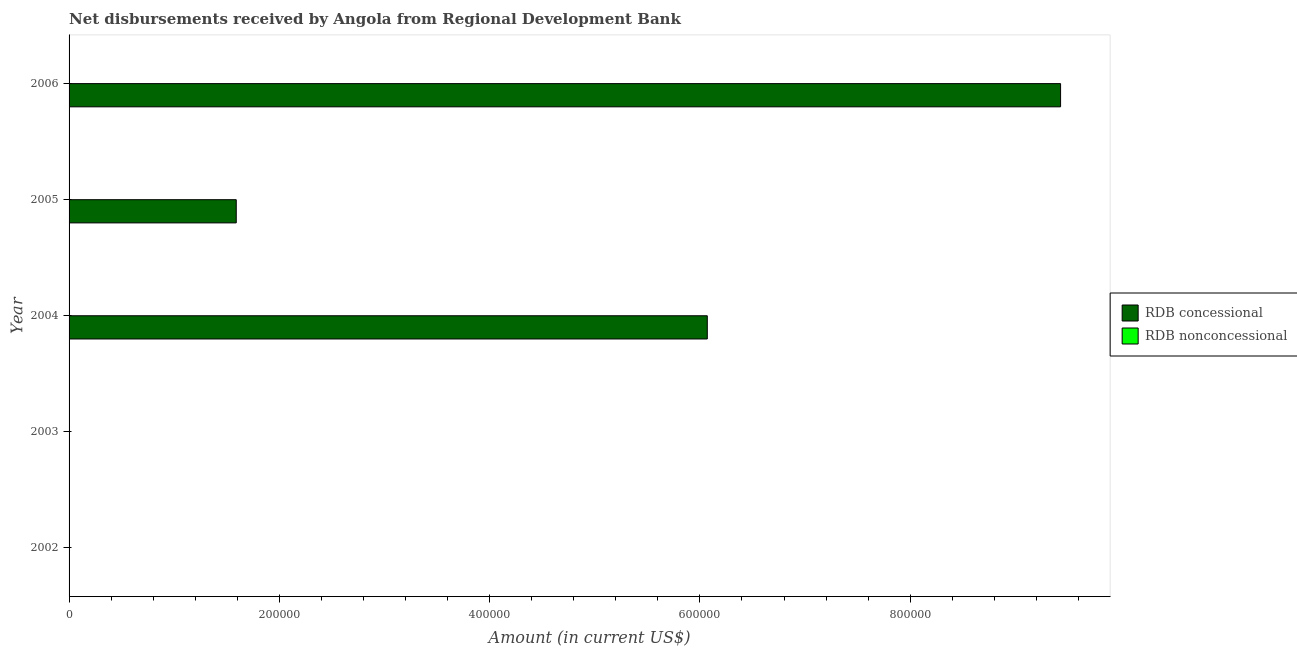How many different coloured bars are there?
Your answer should be compact. 1. How many bars are there on the 4th tick from the top?
Your answer should be compact. 0. Across all years, what is the maximum net concessional disbursements from rdb?
Provide a short and direct response. 9.43e+05. What is the difference between the net concessional disbursements from rdb in 2005 and that in 2006?
Offer a very short reply. -7.84e+05. What is the average net concessional disbursements from rdb per year?
Provide a short and direct response. 3.42e+05. In how many years, is the net non concessional disbursements from rdb greater than 600000 US$?
Provide a short and direct response. 0. What is the ratio of the net concessional disbursements from rdb in 2005 to that in 2006?
Give a very brief answer. 0.17. Is the net concessional disbursements from rdb in 2004 less than that in 2006?
Your answer should be compact. Yes. What is the difference between the highest and the second highest net concessional disbursements from rdb?
Provide a succinct answer. 3.36e+05. What is the difference between the highest and the lowest net concessional disbursements from rdb?
Make the answer very short. 9.43e+05. How many bars are there?
Ensure brevity in your answer.  3. How many years are there in the graph?
Your answer should be very brief. 5. What is the difference between two consecutive major ticks on the X-axis?
Your answer should be very brief. 2.00e+05. Are the values on the major ticks of X-axis written in scientific E-notation?
Your response must be concise. No. Does the graph contain any zero values?
Keep it short and to the point. Yes. Does the graph contain grids?
Provide a short and direct response. No. What is the title of the graph?
Your answer should be compact. Net disbursements received by Angola from Regional Development Bank. Does "Banks" appear as one of the legend labels in the graph?
Your response must be concise. No. What is the label or title of the X-axis?
Your answer should be compact. Amount (in current US$). What is the Amount (in current US$) in RDB nonconcessional in 2002?
Provide a succinct answer. 0. What is the Amount (in current US$) in RDB nonconcessional in 2003?
Your response must be concise. 0. What is the Amount (in current US$) of RDB concessional in 2004?
Ensure brevity in your answer.  6.07e+05. What is the Amount (in current US$) of RDB concessional in 2005?
Ensure brevity in your answer.  1.59e+05. What is the Amount (in current US$) of RDB nonconcessional in 2005?
Keep it short and to the point. 0. What is the Amount (in current US$) in RDB concessional in 2006?
Your answer should be very brief. 9.43e+05. What is the Amount (in current US$) of RDB nonconcessional in 2006?
Ensure brevity in your answer.  0. Across all years, what is the maximum Amount (in current US$) of RDB concessional?
Offer a terse response. 9.43e+05. Across all years, what is the minimum Amount (in current US$) of RDB concessional?
Offer a very short reply. 0. What is the total Amount (in current US$) in RDB concessional in the graph?
Make the answer very short. 1.71e+06. What is the difference between the Amount (in current US$) in RDB concessional in 2004 and that in 2005?
Your answer should be very brief. 4.48e+05. What is the difference between the Amount (in current US$) in RDB concessional in 2004 and that in 2006?
Your answer should be very brief. -3.36e+05. What is the difference between the Amount (in current US$) of RDB concessional in 2005 and that in 2006?
Keep it short and to the point. -7.84e+05. What is the average Amount (in current US$) in RDB concessional per year?
Your response must be concise. 3.42e+05. What is the average Amount (in current US$) in RDB nonconcessional per year?
Offer a very short reply. 0. What is the ratio of the Amount (in current US$) in RDB concessional in 2004 to that in 2005?
Your answer should be compact. 3.82. What is the ratio of the Amount (in current US$) of RDB concessional in 2004 to that in 2006?
Your answer should be very brief. 0.64. What is the ratio of the Amount (in current US$) of RDB concessional in 2005 to that in 2006?
Your answer should be very brief. 0.17. What is the difference between the highest and the second highest Amount (in current US$) of RDB concessional?
Your response must be concise. 3.36e+05. What is the difference between the highest and the lowest Amount (in current US$) of RDB concessional?
Ensure brevity in your answer.  9.43e+05. 